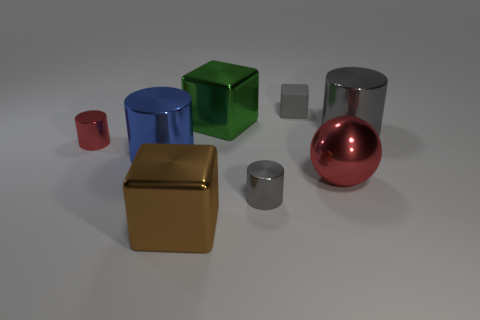What number of objects are in front of the small rubber block and left of the large red thing? Counting the number of objects situated both in front of the small, semi-transparent grey block and to the left of the large red sphere, there appears to be a total of three objects meeting the criteria. 